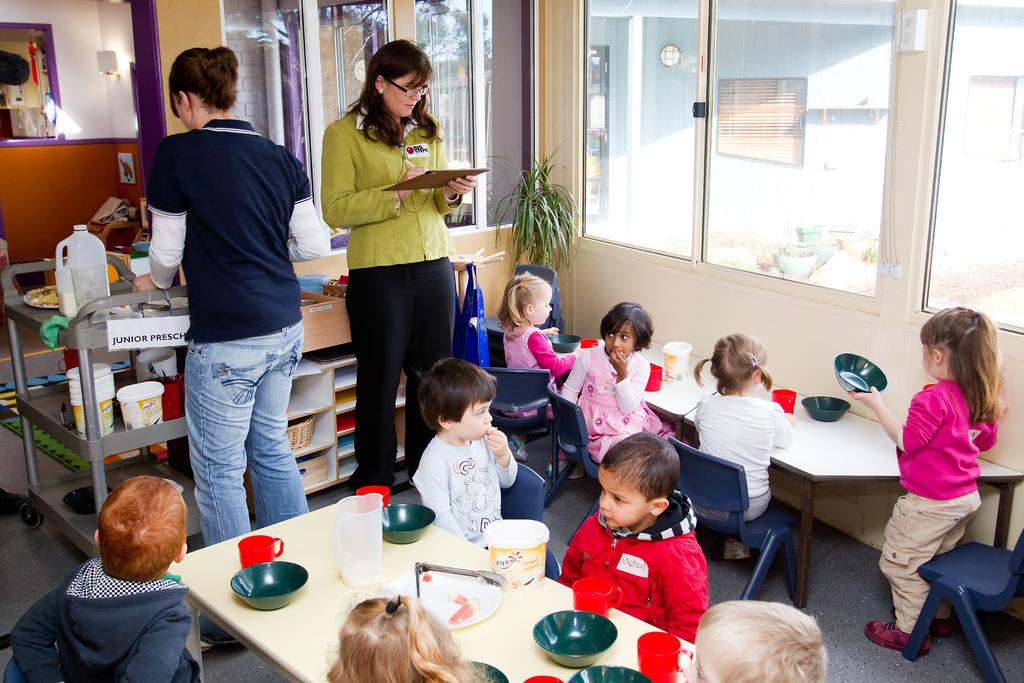What are the children in the image doing? The children in the image are eating food. How is the food being served in the image? The food is in a bowl. What is the woman on the right side of the image doing? The woman on the right side of the image is writing on a paper. Can you describe the woman on the left side of the image? There is another woman standing on the left side of the image. Can you see any tents or the ocean in the image? No, there are no tents or the ocean present in the image. Is there a squirrel visible in the image? No, there is no squirrel visible in the image. 